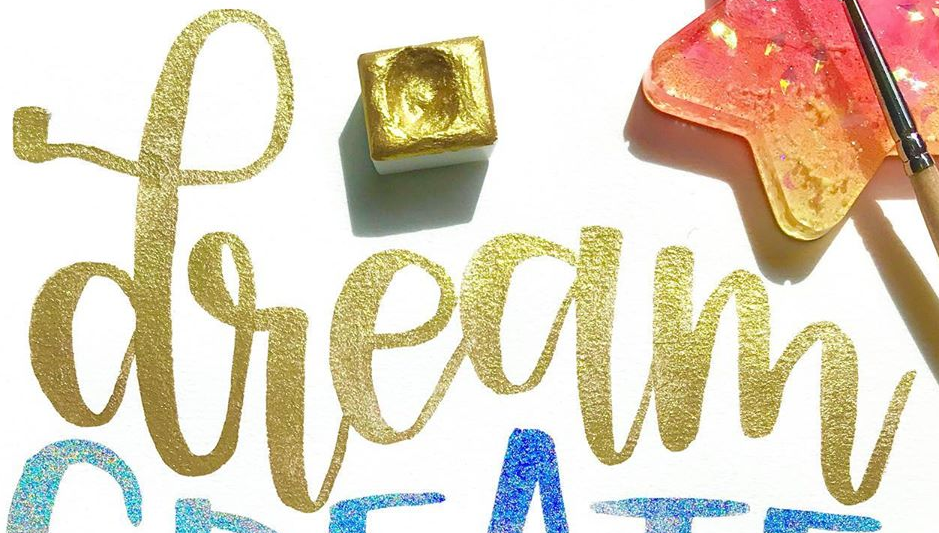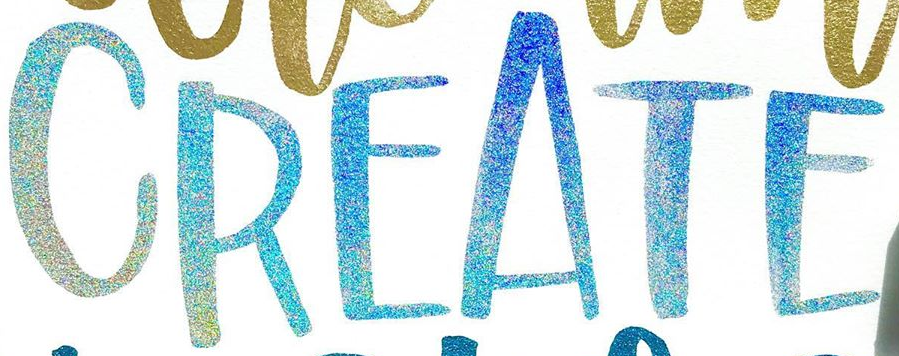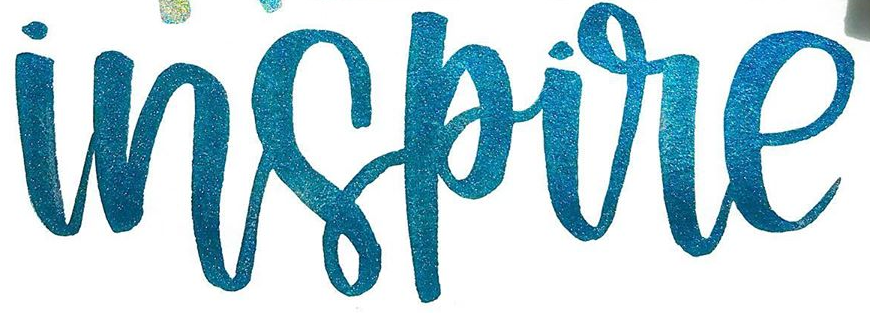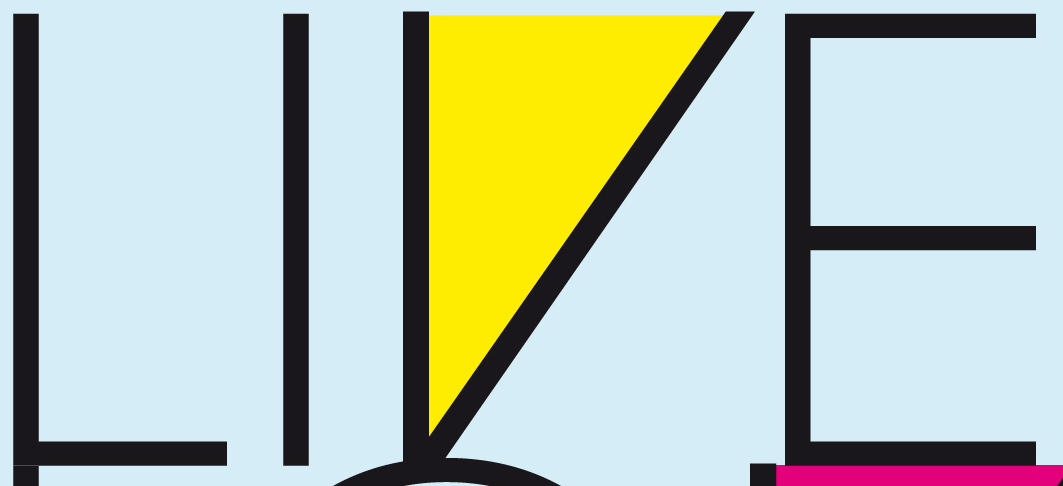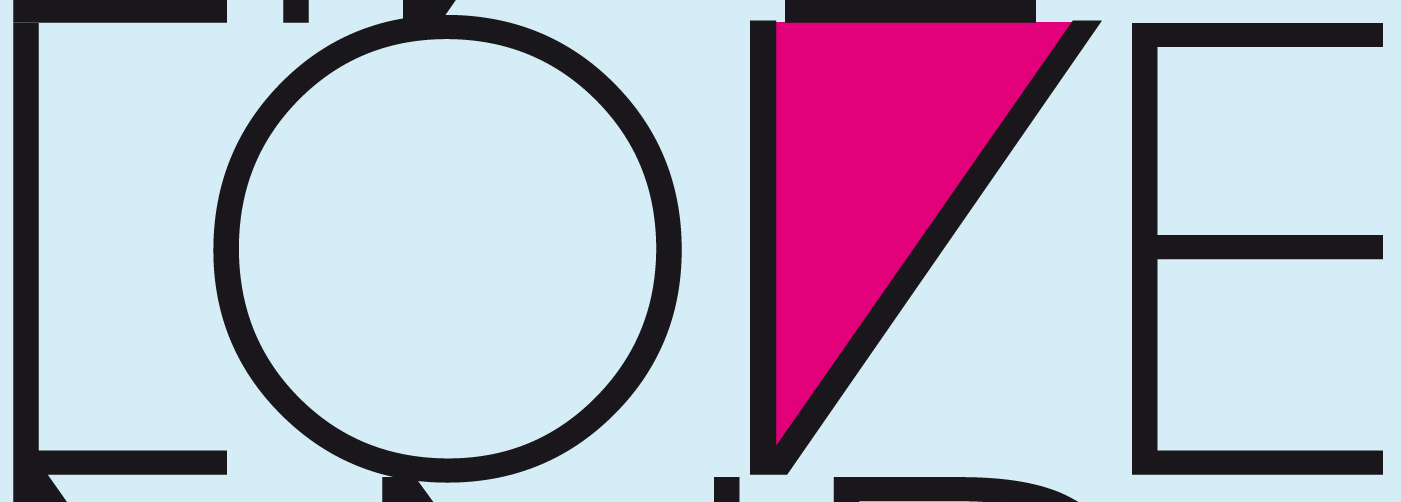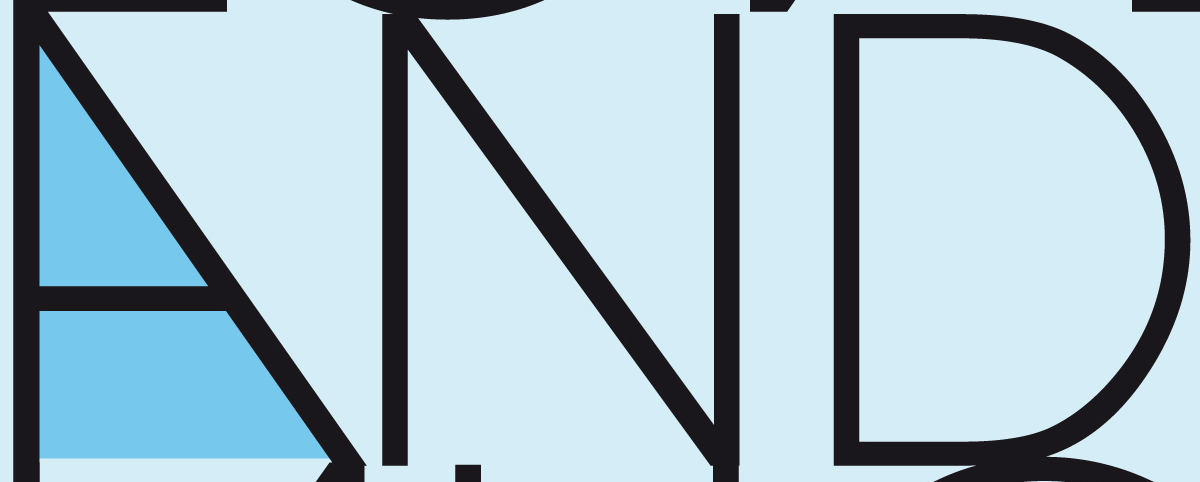What text appears in these images from left to right, separated by a semicolon? dream; CREATE; inspire; LIVE; LOVE; AND 